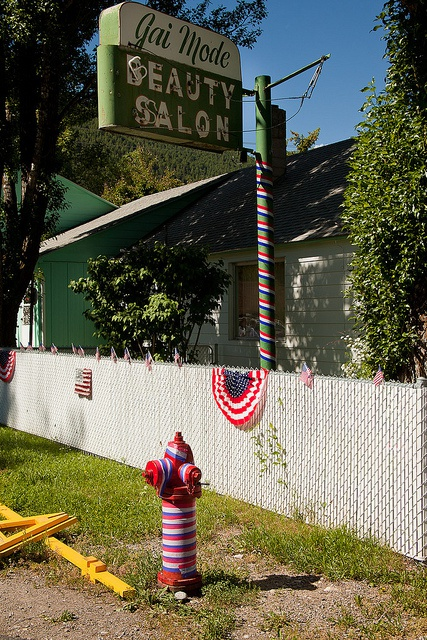Describe the objects in this image and their specific colors. I can see a fire hydrant in black, maroon, lightgray, and gray tones in this image. 